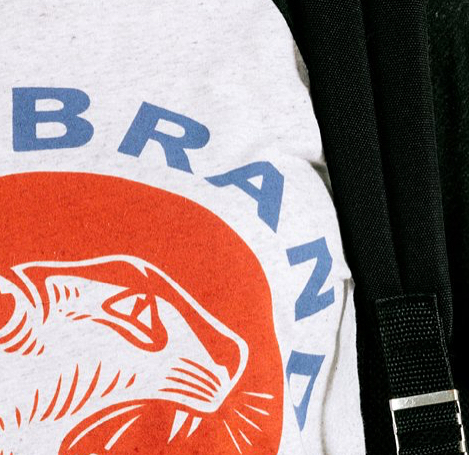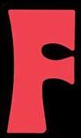What text is displayed in these images sequentially, separated by a semicolon? BRAND; F 